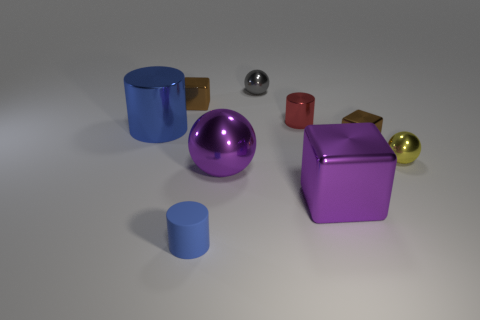Add 1 shiny cylinders. How many objects exist? 10 Subtract all cylinders. How many objects are left? 6 Subtract 1 purple balls. How many objects are left? 8 Subtract all small blue matte things. Subtract all small shiny blocks. How many objects are left? 6 Add 8 tiny rubber cylinders. How many tiny rubber cylinders are left? 9 Add 9 large yellow objects. How many large yellow objects exist? 9 